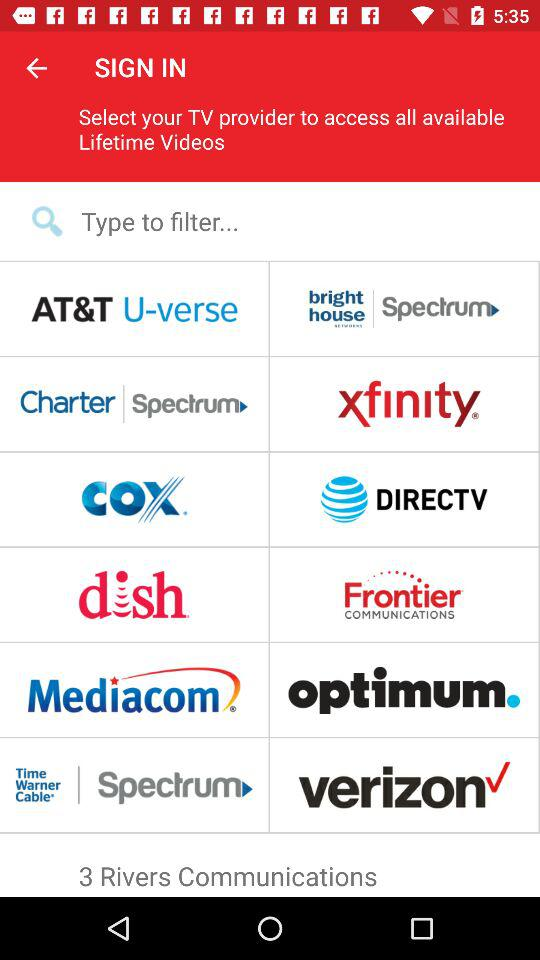What's the number of "Rivers Communications"? There are three "Rivers Communications". 